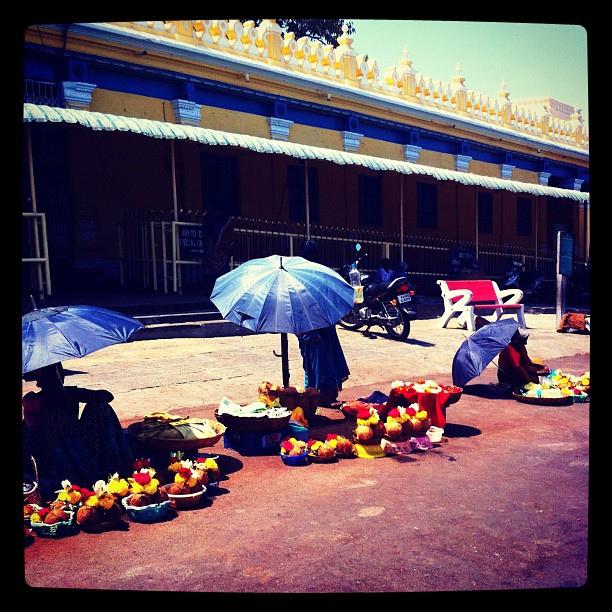What color is the umbrella?
Keep it brief. Blue. Are the people happy?
Answer briefly. Yes. How many umbrellas are there?
Keep it brief. 3. Is it raining?
Write a very short answer. No. What is below the umbrellas?
Answer briefly. Fruit. What vacation destination is this?
Be succinct. Bali. Is this a street market?
Short answer required. Yes. 